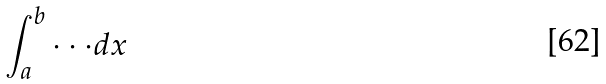<formula> <loc_0><loc_0><loc_500><loc_500>\int _ { a } ^ { b } \cdot \cdot \cdot d x</formula> 